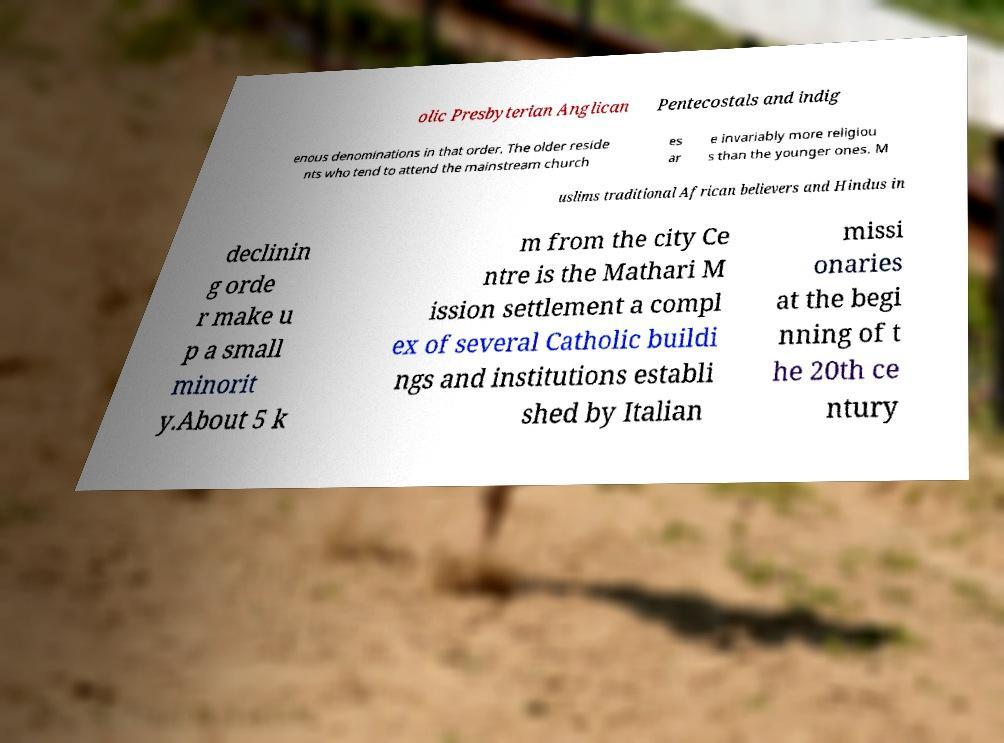I need the written content from this picture converted into text. Can you do that? olic Presbyterian Anglican Pentecostals and indig enous denominations in that order. The older reside nts who tend to attend the mainstream church es ar e invariably more religiou s than the younger ones. M uslims traditional African believers and Hindus in declinin g orde r make u p a small minorit y.About 5 k m from the city Ce ntre is the Mathari M ission settlement a compl ex of several Catholic buildi ngs and institutions establi shed by Italian missi onaries at the begi nning of t he 20th ce ntury 